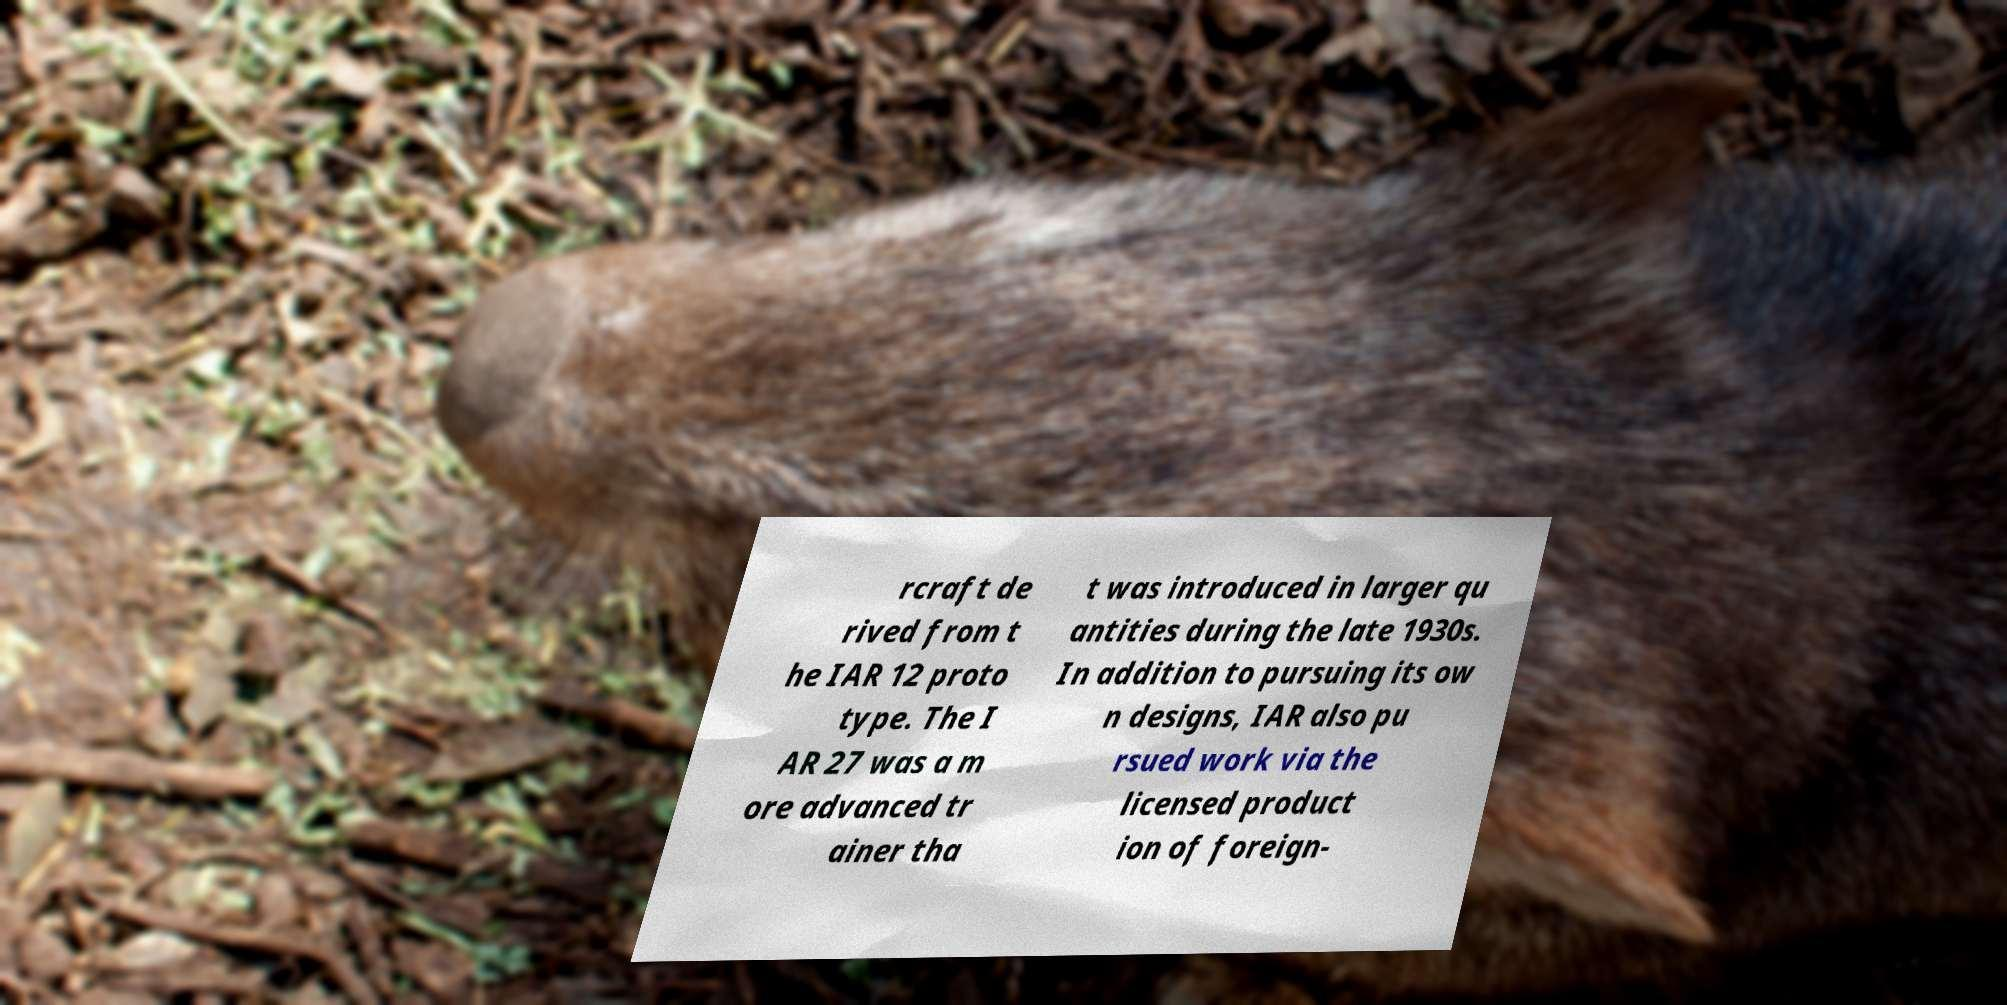Can you read and provide the text displayed in the image?This photo seems to have some interesting text. Can you extract and type it out for me? rcraft de rived from t he IAR 12 proto type. The I AR 27 was a m ore advanced tr ainer tha t was introduced in larger qu antities during the late 1930s. In addition to pursuing its ow n designs, IAR also pu rsued work via the licensed product ion of foreign- 